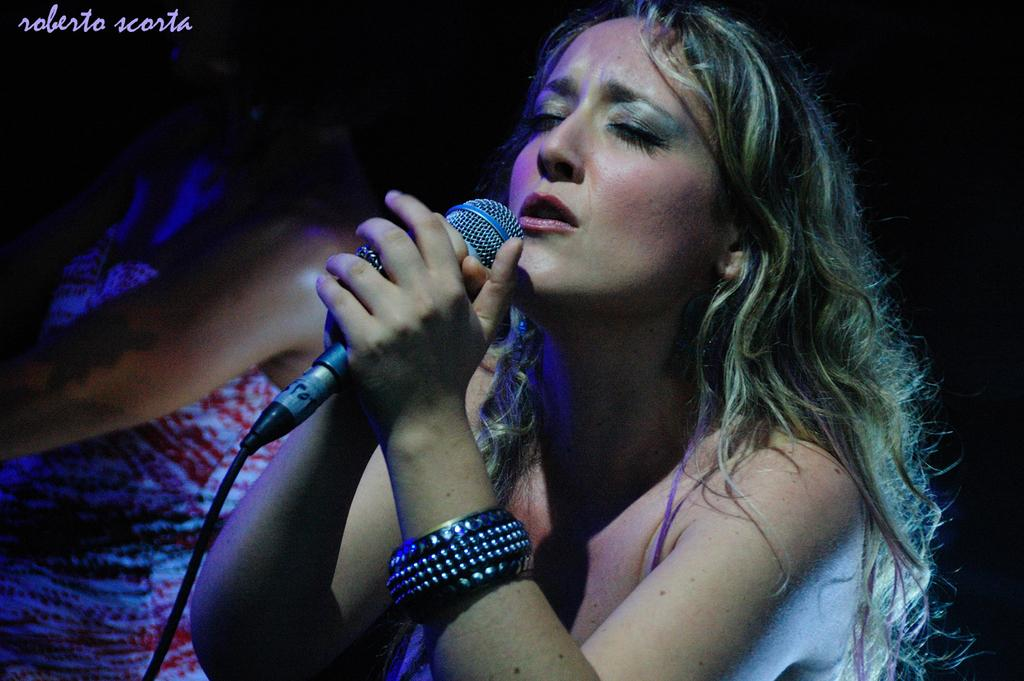How many people are in the image? There is a group of people in the image. What is the woman in the image doing? The woman is singing in the image. What tool is the woman using while singing? The woman is using a microphone while singing. How much money is the woman holding in her knee while singing? There is no mention of money or the woman holding anything in her knee in the image. 